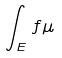Convert formula to latex. <formula><loc_0><loc_0><loc_500><loc_500>\int _ { E } f \mu</formula> 